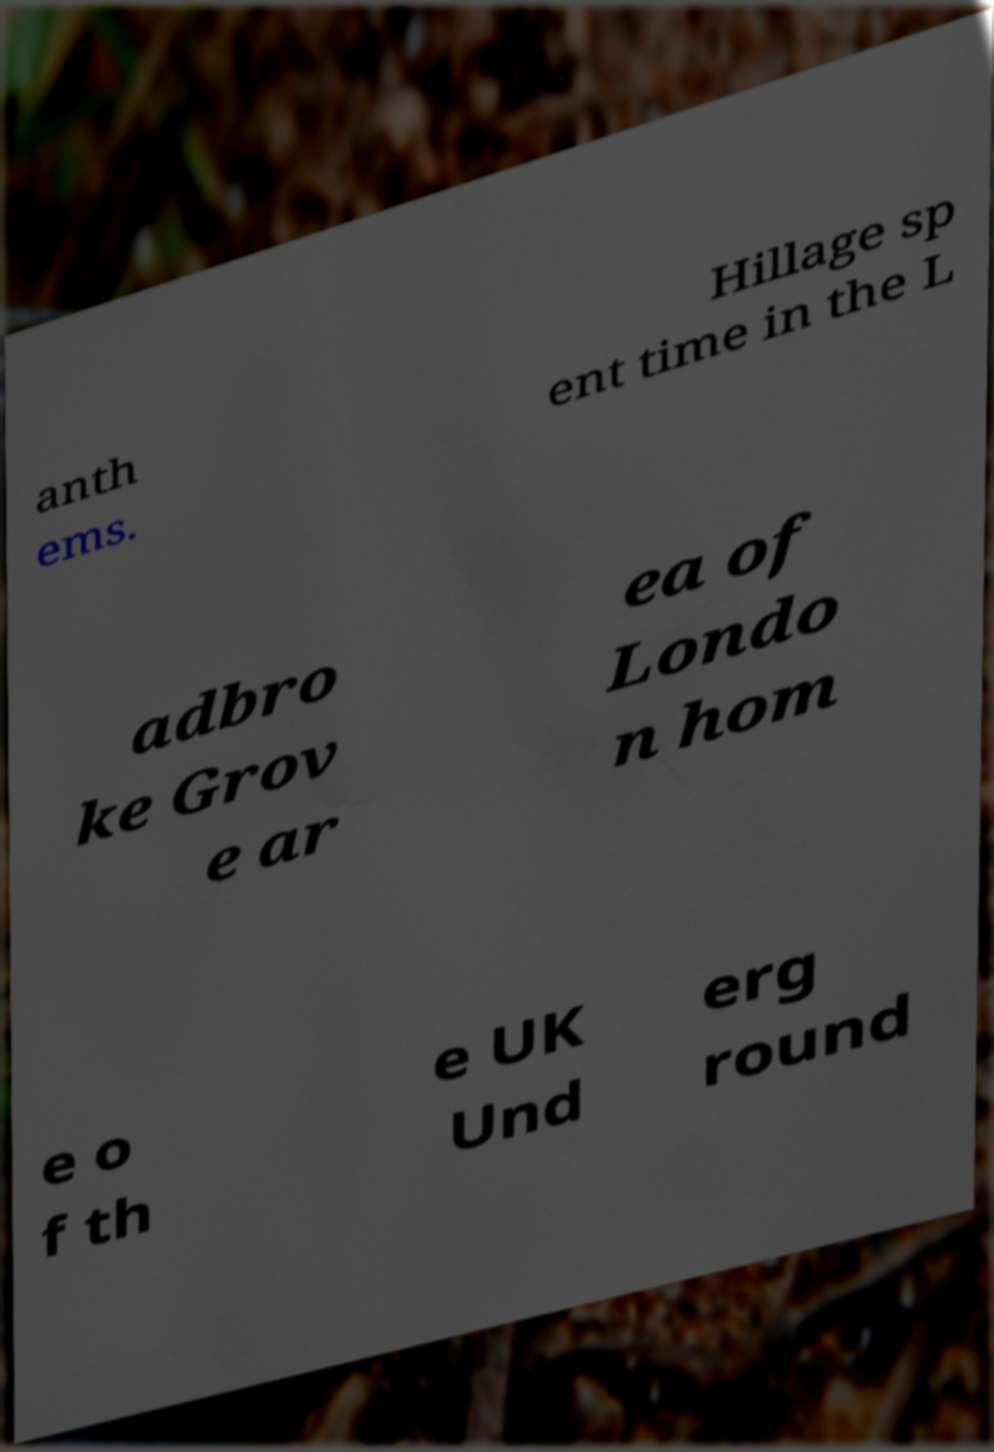Can you accurately transcribe the text from the provided image for me? anth ems. Hillage sp ent time in the L adbro ke Grov e ar ea of Londo n hom e o f th e UK Und erg round 